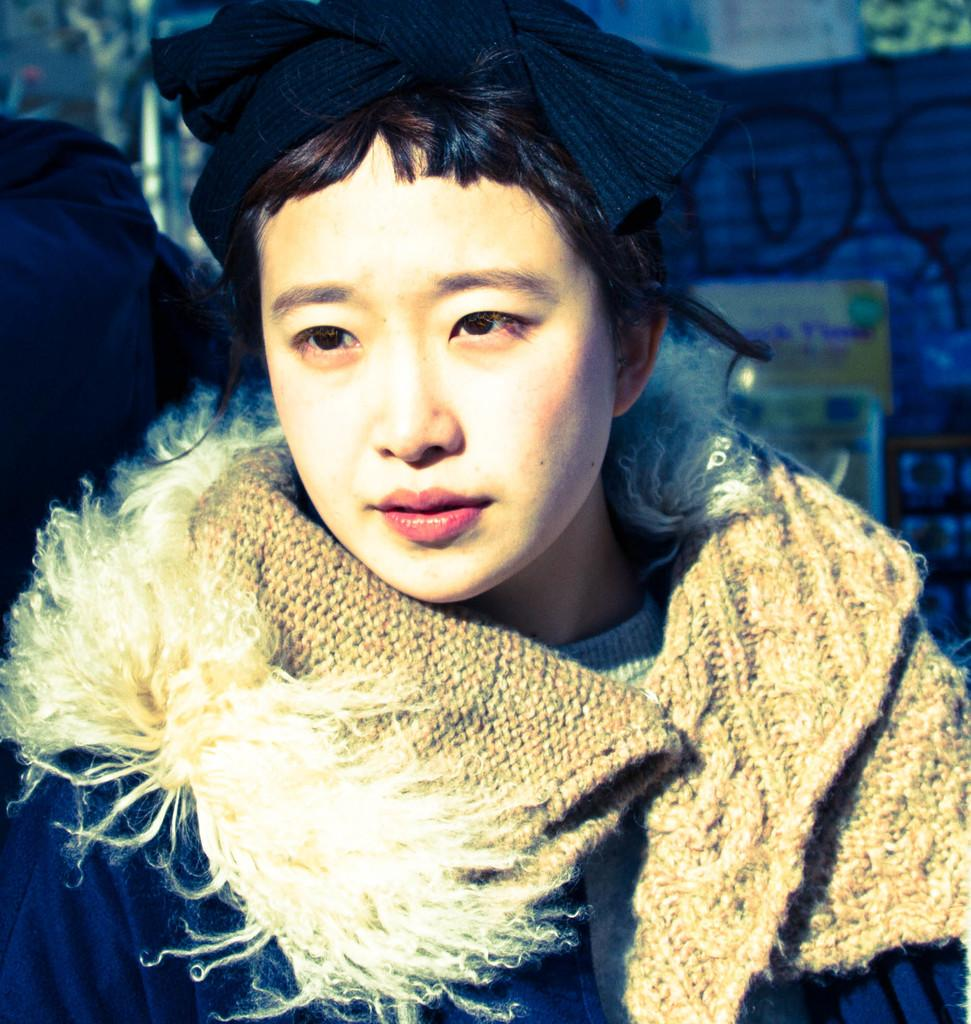Who is present in the image? There is a person in the image. What is the person wearing? The person is wearing a jacket. What can be seen in the background of the image? There is a wall in the background of the image. What is on the wall? There is graffiti on the wall. What song is the person singing in the image? There is no indication in the image that the person is singing, so it cannot be determined from the picture. 